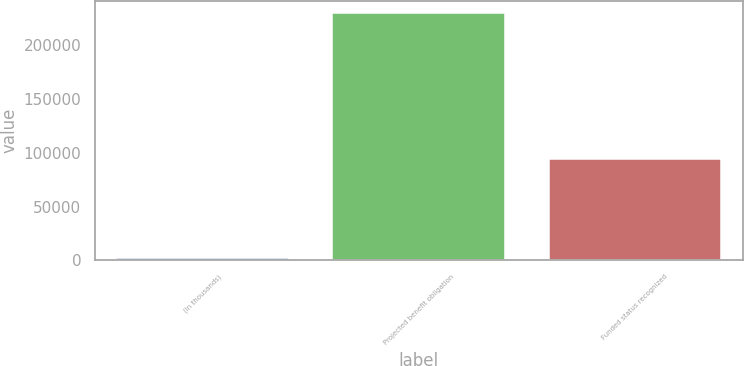<chart> <loc_0><loc_0><loc_500><loc_500><bar_chart><fcel>(In thousands)<fcel>Projected benefit obligation<fcel>Funded status recognized<nl><fcel>2015<fcel>229241<fcel>93992<nl></chart> 